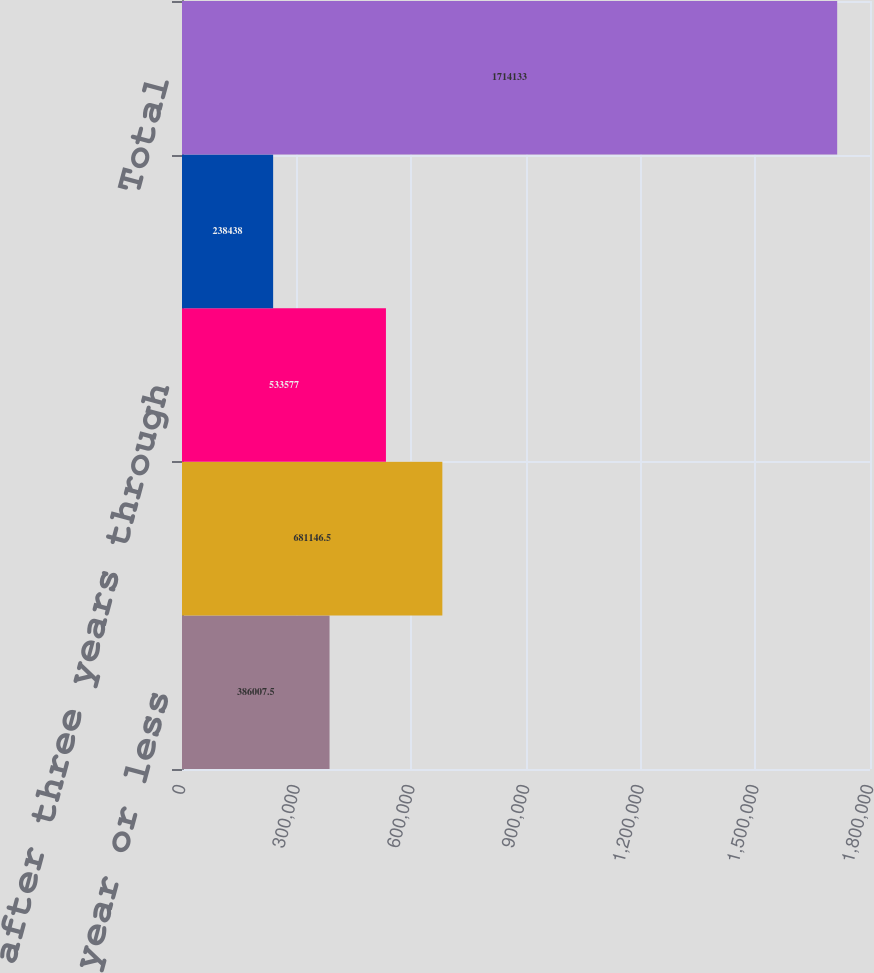Convert chart. <chart><loc_0><loc_0><loc_500><loc_500><bar_chart><fcel>Due in one year or less<fcel>Due after one year through<fcel>Due after three years through<fcel>Due after five years<fcel>Total<nl><fcel>386008<fcel>681146<fcel>533577<fcel>238438<fcel>1.71413e+06<nl></chart> 